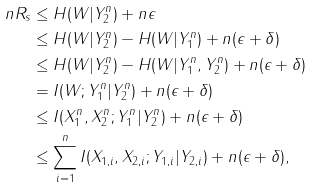Convert formula to latex. <formula><loc_0><loc_0><loc_500><loc_500>n R _ { s } & \leq H ( W | Y _ { 2 } ^ { n } ) + n \epsilon \\ & \leq H ( W | Y _ { 2 } ^ { n } ) - H ( W | Y _ { 1 } ^ { n } ) + n ( \epsilon + \delta ) \\ & \leq H ( W | Y _ { 2 } ^ { n } ) - H ( W | Y _ { 1 } ^ { n } , Y _ { 2 } ^ { n } ) + n ( \epsilon + \delta ) \\ & = I ( W ; Y _ { 1 } ^ { n } | Y _ { 2 } ^ { n } ) + n ( \epsilon + \delta ) \\ & \leq I ( X _ { 1 } ^ { n } , X _ { 2 } ^ { n } ; Y _ { 1 } ^ { n } | Y _ { 2 } ^ { n } ) + n ( \epsilon + \delta ) \\ & \leq \sum _ { i = 1 } ^ { n } I ( X _ { 1 , i } , X _ { 2 , i } ; Y _ { 1 , i } | Y _ { 2 , i } ) + n ( \epsilon + \delta ) ,</formula> 